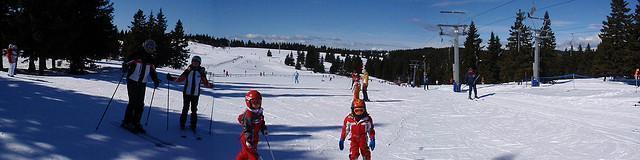What are the metal towers used for?
Pick the right solution, then justify: 'Answer: answer
Rationale: rationale.'
Options: Cell phones, transportation, climbing, gaming. Answer: transportation.
Rationale: The metal towers are used for transporting people on the slope. 